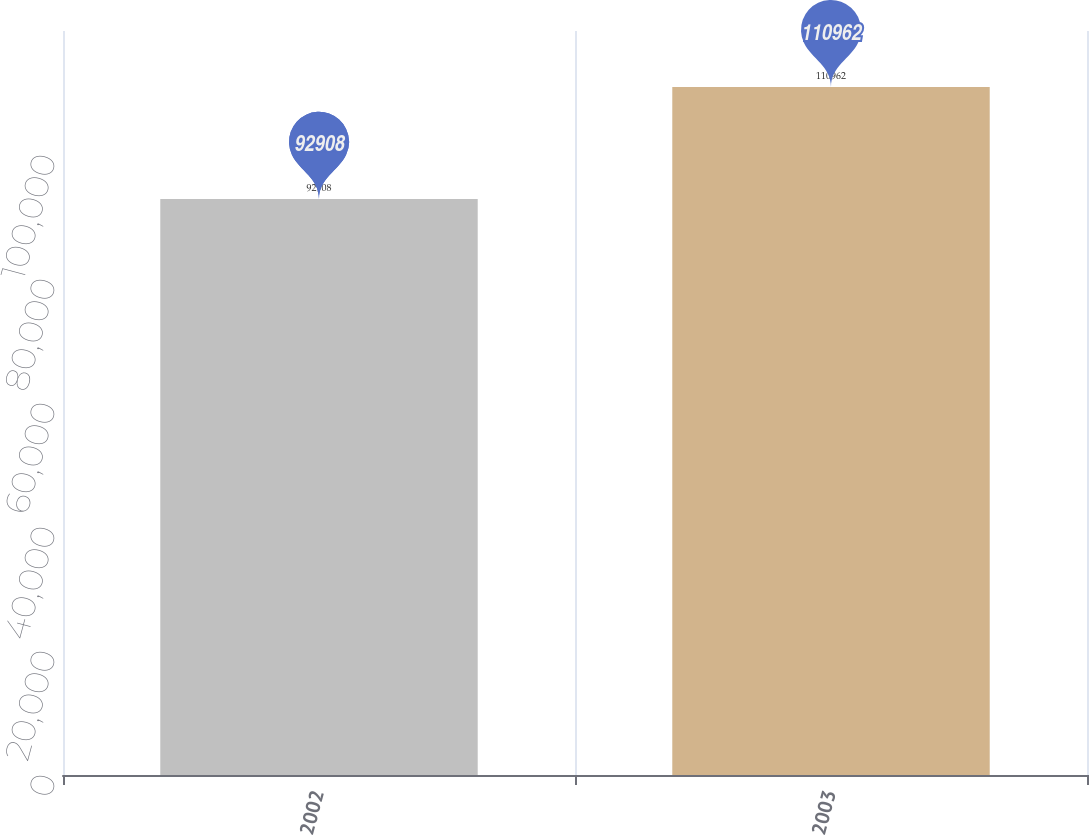Convert chart. <chart><loc_0><loc_0><loc_500><loc_500><bar_chart><fcel>2002<fcel>2003<nl><fcel>92908<fcel>110962<nl></chart> 